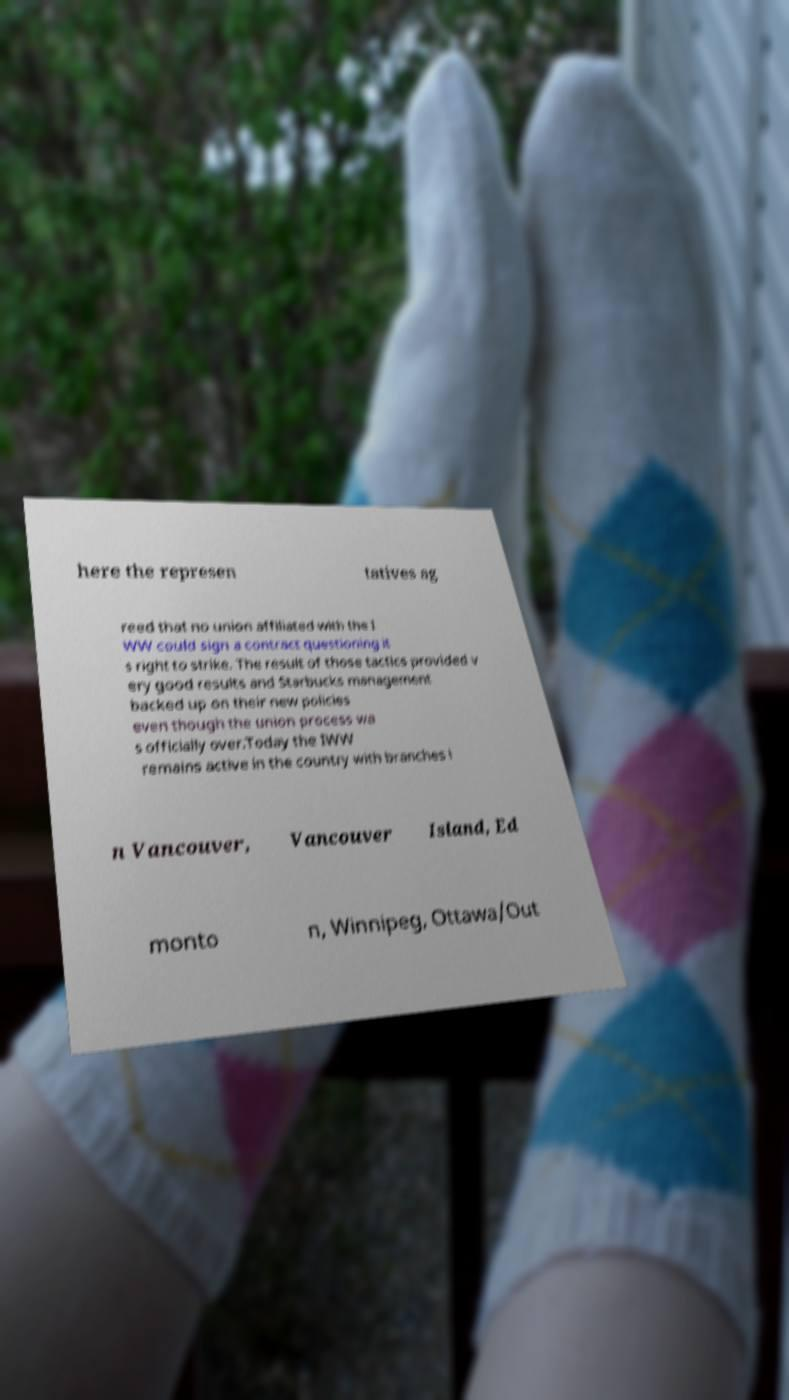There's text embedded in this image that I need extracted. Can you transcribe it verbatim? here the represen tatives ag reed that no union affiliated with the I WW could sign a contract questioning it s right to strike. The result of those tactics provided v ery good results and Starbucks management backed up on their new policies even though the union process wa s officially over.Today the IWW remains active in the country with branches i n Vancouver, Vancouver Island, Ed monto n, Winnipeg, Ottawa/Out 